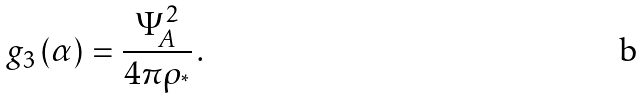<formula> <loc_0><loc_0><loc_500><loc_500>g _ { 3 } \left ( \alpha \right ) = \frac { \Psi _ { A } ^ { 2 } } { 4 \pi \rho _ { ^ { * } } } \, .</formula> 